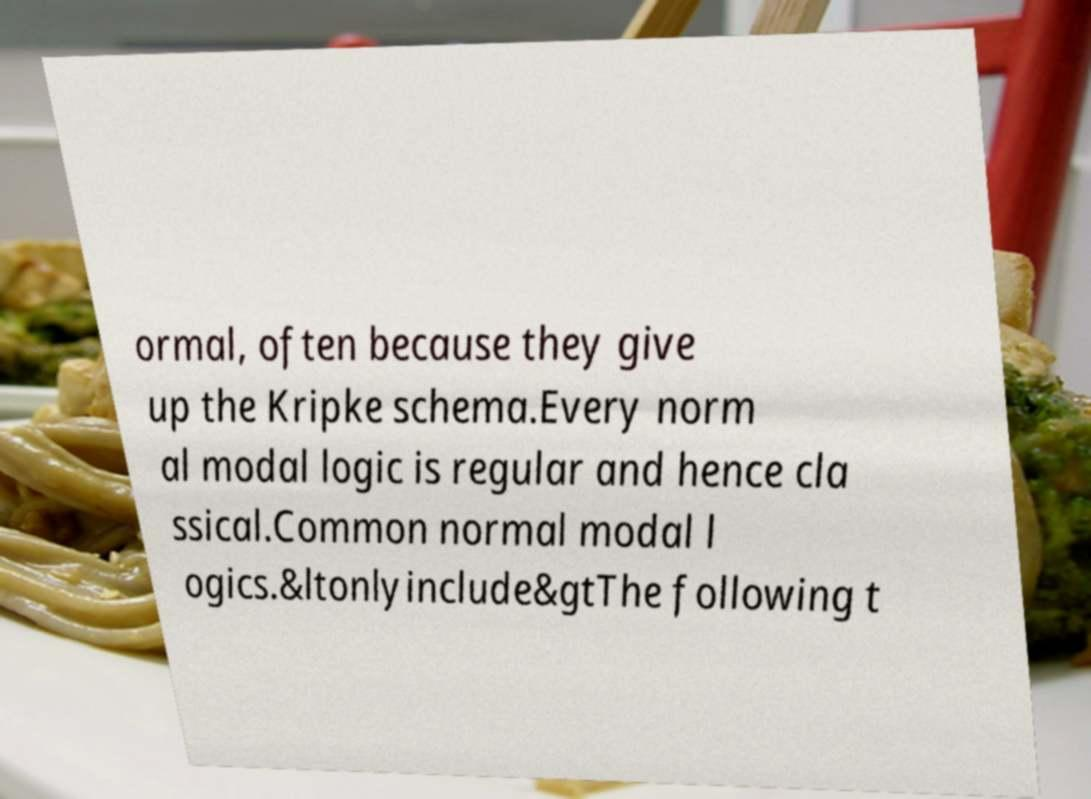I need the written content from this picture converted into text. Can you do that? ormal, often because they give up the Kripke schema.Every norm al modal logic is regular and hence cla ssical.Common normal modal l ogics.&ltonlyinclude&gtThe following t 